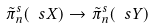<formula> <loc_0><loc_0><loc_500><loc_500>\tilde { \pi } ^ { s } _ { n } ( \ s X ) \rightarrow \tilde { \pi } ^ { s } _ { n } ( \ s Y )</formula> 